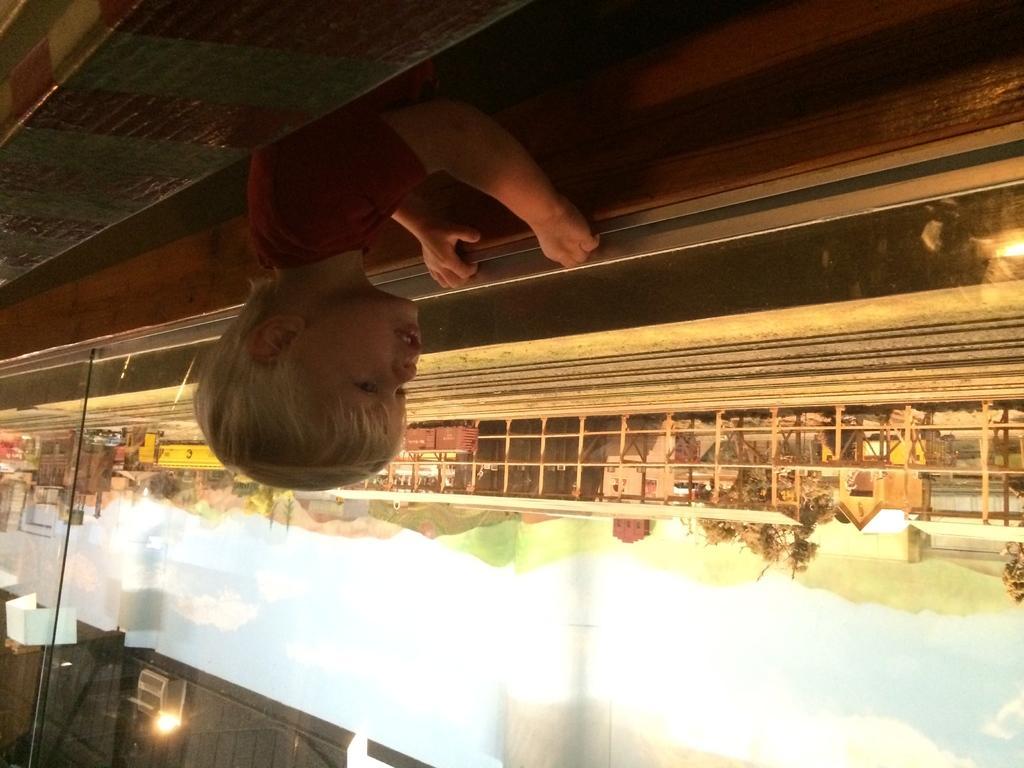Could you give a brief overview of what you see in this image? In this picture we can see a child, fence, buildings, trees, lights and in the background we can see the sky with clouds. 